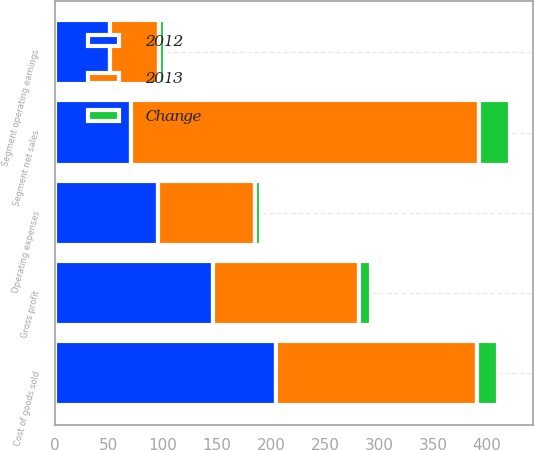<chart> <loc_0><loc_0><loc_500><loc_500><stacked_bar_chart><ecel><fcel>Segment net sales<fcel>Cost of goods sold<fcel>Gross profit<fcel>Operating expenses<fcel>Segment operating earnings<nl><fcel>2012<fcel>70.6<fcel>204.9<fcel>146.2<fcel>95.2<fcel>51<nl><fcel>2013<fcel>321.6<fcel>185.8<fcel>135.8<fcel>90.2<fcel>45.6<nl><fcel>Change<fcel>29.5<fcel>19.1<fcel>10.4<fcel>5<fcel>5.4<nl></chart> 